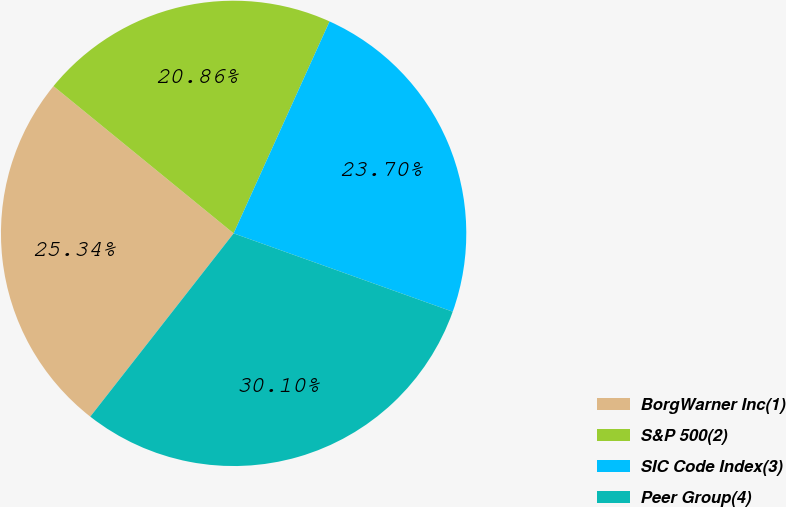Convert chart. <chart><loc_0><loc_0><loc_500><loc_500><pie_chart><fcel>BorgWarner Inc(1)<fcel>S&P 500(2)<fcel>SIC Code Index(3)<fcel>Peer Group(4)<nl><fcel>25.34%<fcel>20.86%<fcel>23.7%<fcel>30.1%<nl></chart> 